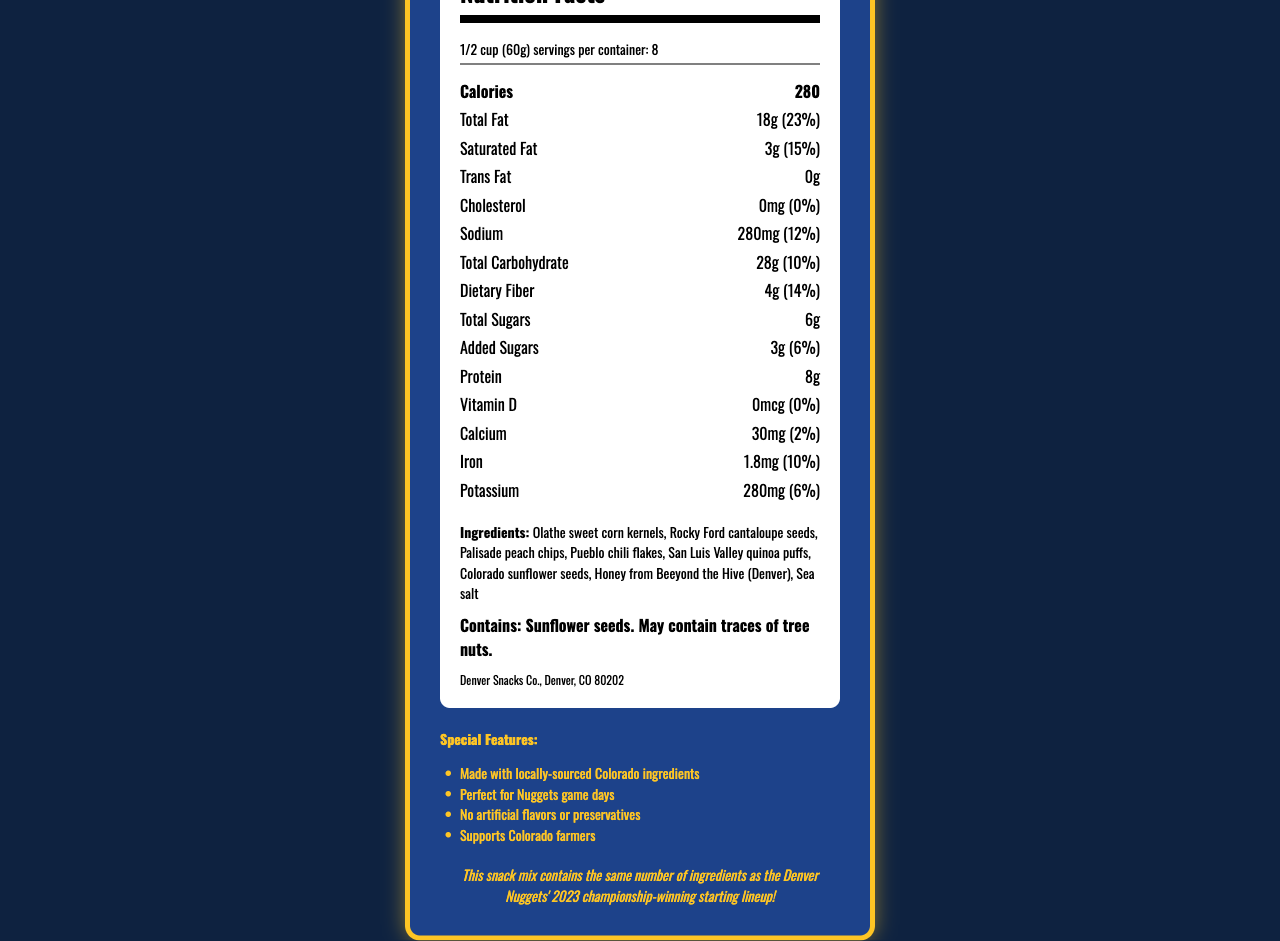what is the serving size? The serving size is listed under the "Nutrition Facts" section as "1/2 cup (60g)".
Answer: 1/2 cup (60g) how many servings are in one container? The document specifies "servings per container: 8" in the "Nutrition Facts" section.
Answer: 8 how many calories are in one serving? The number of calories per serving is listed as "Calories: 280" in the "Nutrition Facts" section.
Answer: 280 calories what is the total fat content in one serving? The total fat content is mentioned in the "Nutrition Facts" section as "Total Fat: 18g".
Answer: 18g which ingredient is sourced from Denver? The ingredients list includes "Honey from Beeyond the Hive (Denver)" which indicates that it is sourced from Denver.
Answer: Honey from Beeyond the Hive what is the daily value percentage for sodium? The daily value percentage for sodium is listed in the "Nutrition Facts" section as "Sodium: 280mg (12%)".
Answer: 12% how many grams of dietary fiber does one serving have? The serving contains "Dietary Fiber: 4g" as noted in the "Nutrition Facts" section.
Answer: 4g [Multiple Choice] which of the following is a special feature of the Mile High Game Day Snack Mix?  
A. Gluten-Free  
B. No artificial flavors or preservatives  
C. Contains tree nuts  
D. Contains dairy The document lists "No artificial flavors or preservatives" as one of the special features.
Answer: B [Multiple Choice] what is the manufacturer address?
i. Denver, CO 80201
ii. Boulder, CO 80301
iii. Denver, CO 80202
iv. Fort Collins, CO 80521 The manufacturer is listed as "Denver Snacks Co., Denver, CO 80202".
Answer: iii. Denver, CO 80202 is the snack mix perfect for Denver Nuggets game days? One of the special features listed is "Perfect for Nuggets game days".
Answer: Yes summarize the main idea of the document The document covers comprehensive information about the snack mix, from nutrition details to locally-sourced ingredients, making it ideal for supporting local farmers and enjoying during Nuggets games.
Answer: The document provides the nutrition facts, ingredients list, special features, allergen information, and manufacturer details for the Mile High Game Day Snack Mix. It highlights the use of locally sourced Colorado ingredients and suitability for Denver Nuggets game days. what is the exact amount of Vitamin C in the snack mix? The document does not provide any information about the amount of Vitamin C in the snack mix.
Answer: Not enough information 